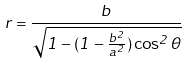<formula> <loc_0><loc_0><loc_500><loc_500>r = \frac { b } { \sqrt { 1 - ( 1 - \frac { b ^ { 2 } } { a ^ { 2 } } ) \cos ^ { 2 } \theta } }</formula> 